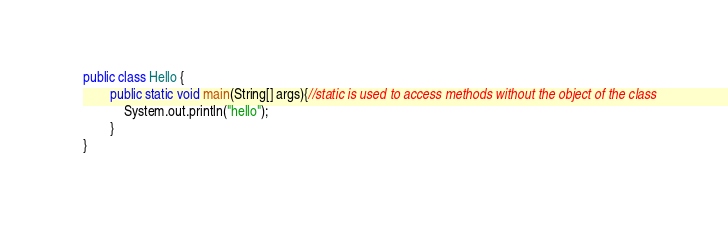<code> <loc_0><loc_0><loc_500><loc_500><_Java_>public class Hello {
        public static void main(String[] args){//static is used to access methods without the object of the class
            System.out.println("hello");
        }
}
</code> 